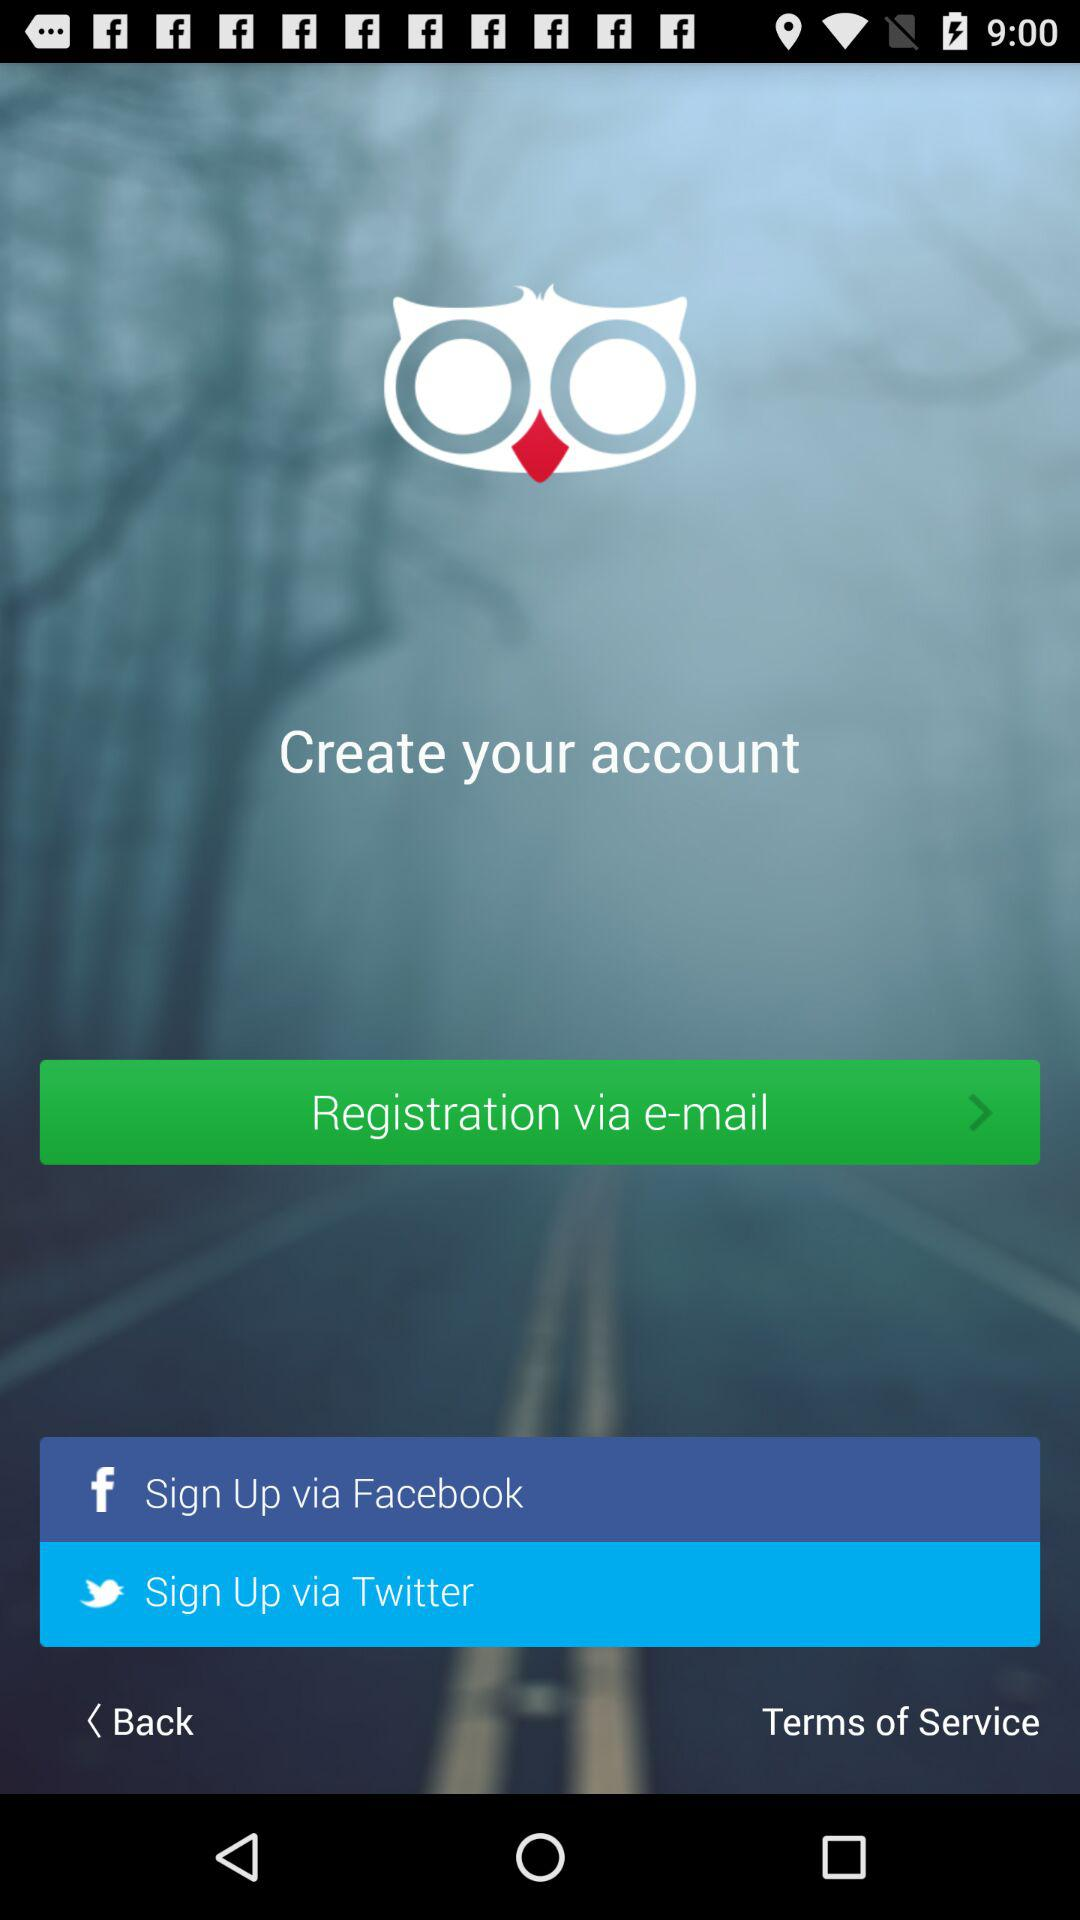What are the different options available for sign up? The different options available are "Facebook" and "Twitter". 